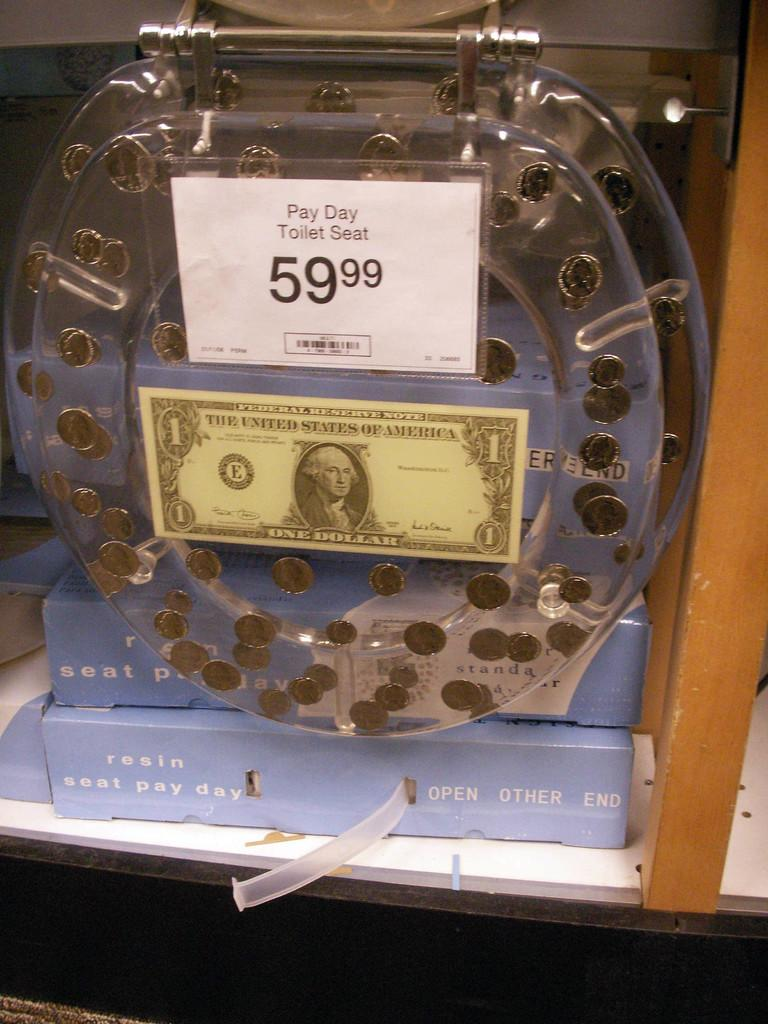<image>
Render a clear and concise summary of the photo. "Pay Day Toilet Seat" a clear toilet seat with coins embedded inside on sale for 59.99 